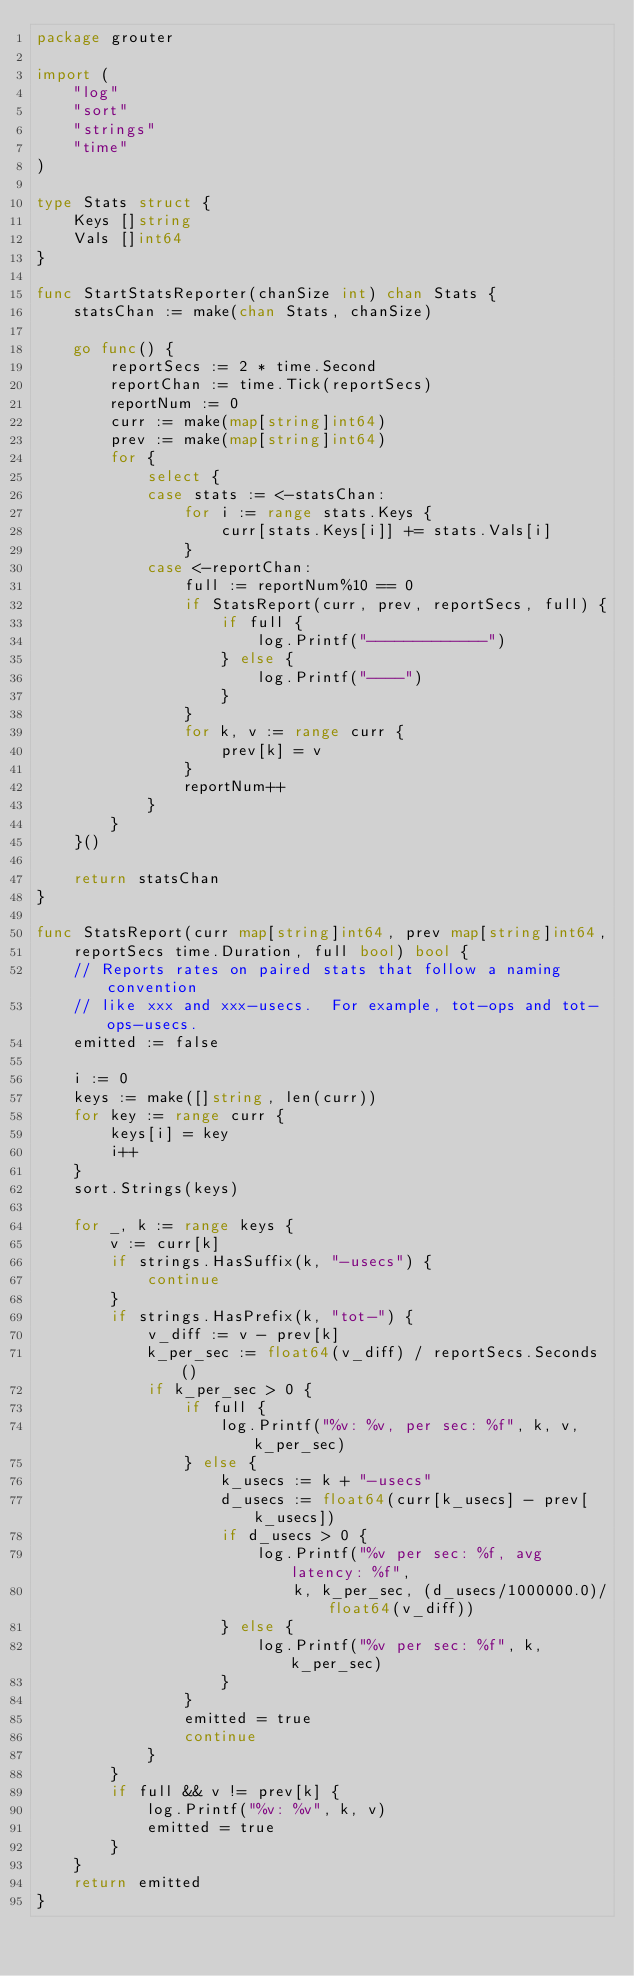Convert code to text. <code><loc_0><loc_0><loc_500><loc_500><_Go_>package grouter

import (
	"log"
	"sort"
	"strings"
	"time"
)

type Stats struct {
	Keys []string
	Vals []int64
}

func StartStatsReporter(chanSize int) chan Stats {
	statsChan := make(chan Stats, chanSize)

	go func() {
		reportSecs := 2 * time.Second
		reportChan := time.Tick(reportSecs)
		reportNum := 0
		curr := make(map[string]int64)
		prev := make(map[string]int64)
		for {
			select {
			case stats := <-statsChan:
				for i := range stats.Keys {
					curr[stats.Keys[i]] += stats.Vals[i]
				}
			case <-reportChan:
				full := reportNum%10 == 0
				if StatsReport(curr, prev, reportSecs, full) {
					if full {
						log.Printf("-------------")
					} else {
						log.Printf("----")
					}
				}
				for k, v := range curr {
					prev[k] = v
				}
				reportNum++
			}
		}
	}()

	return statsChan
}

func StatsReport(curr map[string]int64, prev map[string]int64,
	reportSecs time.Duration, full bool) bool {
	// Reports rates on paired stats that follow a naming convention
	// like xxx and xxx-usecs.  For example, tot-ops and tot-ops-usecs.
	emitted := false

	i := 0
	keys := make([]string, len(curr))
	for key := range curr {
		keys[i] = key
		i++
	}
	sort.Strings(keys)

	for _, k := range keys {
		v := curr[k]
		if strings.HasSuffix(k, "-usecs") {
			continue
		}
		if strings.HasPrefix(k, "tot-") {
			v_diff := v - prev[k]
			k_per_sec := float64(v_diff) / reportSecs.Seconds()
			if k_per_sec > 0 {
				if full {
					log.Printf("%v: %v, per sec: %f", k, v, k_per_sec)
				} else {
					k_usecs := k + "-usecs"
					d_usecs := float64(curr[k_usecs] - prev[k_usecs])
					if d_usecs > 0 {
						log.Printf("%v per sec: %f, avg latency: %f",
							k, k_per_sec, (d_usecs/1000000.0)/float64(v_diff))
					} else {
						log.Printf("%v per sec: %f", k, k_per_sec)
					}
				}
				emitted = true
				continue
			}
		}
		if full && v != prev[k] {
			log.Printf("%v: %v", k, v)
			emitted = true
		}
	}
	return emitted
}
</code> 